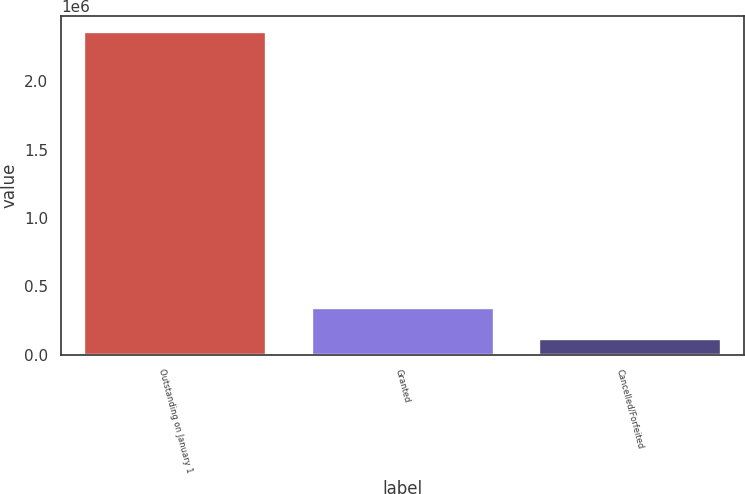Convert chart. <chart><loc_0><loc_0><loc_500><loc_500><bar_chart><fcel>Outstanding on January 1<fcel>Granted<fcel>Cancelled/Forfeited<nl><fcel>2.35673e+06<fcel>338685<fcel>114458<nl></chart> 